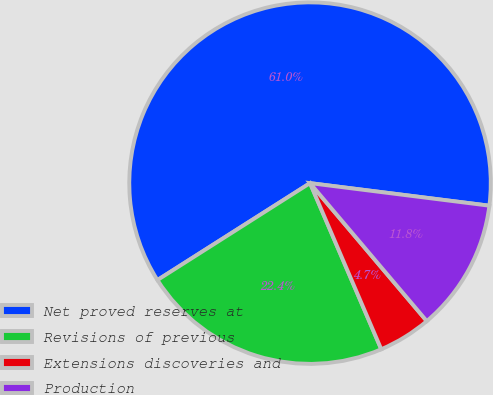<chart> <loc_0><loc_0><loc_500><loc_500><pie_chart><fcel>Net proved reserves at<fcel>Revisions of previous<fcel>Extensions discoveries and<fcel>Production<nl><fcel>61.0%<fcel>22.44%<fcel>4.73%<fcel>11.83%<nl></chart> 